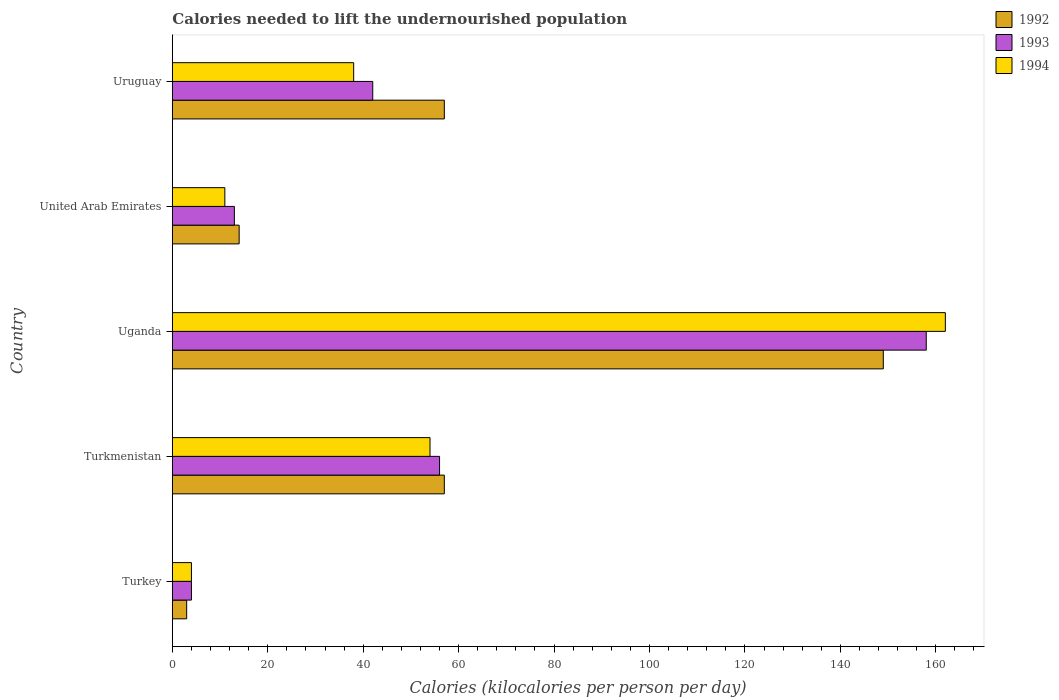How many groups of bars are there?
Your answer should be very brief. 5. Are the number of bars on each tick of the Y-axis equal?
Give a very brief answer. Yes. What is the label of the 2nd group of bars from the top?
Offer a very short reply. United Arab Emirates. Across all countries, what is the maximum total calories needed to lift the undernourished population in 1992?
Your response must be concise. 149. In which country was the total calories needed to lift the undernourished population in 1994 maximum?
Your response must be concise. Uganda. What is the total total calories needed to lift the undernourished population in 1992 in the graph?
Your answer should be very brief. 280. What is the difference between the total calories needed to lift the undernourished population in 1992 in United Arab Emirates and that in Uruguay?
Your answer should be compact. -43. What is the difference between the total calories needed to lift the undernourished population in 1992 in Turkmenistan and the total calories needed to lift the undernourished population in 1993 in Turkey?
Your answer should be compact. 53. What is the average total calories needed to lift the undernourished population in 1992 per country?
Provide a short and direct response. 56. In how many countries, is the total calories needed to lift the undernourished population in 1994 greater than 116 kilocalories?
Ensure brevity in your answer.  1. What is the ratio of the total calories needed to lift the undernourished population in 1993 in Uganda to that in Uruguay?
Offer a terse response. 3.76. Is the total calories needed to lift the undernourished population in 1994 in Turkey less than that in Uruguay?
Keep it short and to the point. Yes. What is the difference between the highest and the second highest total calories needed to lift the undernourished population in 1992?
Your response must be concise. 92. What is the difference between the highest and the lowest total calories needed to lift the undernourished population in 1993?
Your response must be concise. 154. Is the sum of the total calories needed to lift the undernourished population in 1992 in United Arab Emirates and Uruguay greater than the maximum total calories needed to lift the undernourished population in 1994 across all countries?
Give a very brief answer. No. What does the 3rd bar from the top in Uruguay represents?
Your answer should be very brief. 1992. What does the 2nd bar from the bottom in Turkmenistan represents?
Your answer should be compact. 1993. Is it the case that in every country, the sum of the total calories needed to lift the undernourished population in 1994 and total calories needed to lift the undernourished population in 1992 is greater than the total calories needed to lift the undernourished population in 1993?
Make the answer very short. Yes. How many bars are there?
Provide a short and direct response. 15. Are all the bars in the graph horizontal?
Provide a short and direct response. Yes. How many countries are there in the graph?
Keep it short and to the point. 5. What is the difference between two consecutive major ticks on the X-axis?
Your answer should be very brief. 20. Are the values on the major ticks of X-axis written in scientific E-notation?
Offer a terse response. No. Does the graph contain grids?
Give a very brief answer. No. How are the legend labels stacked?
Offer a terse response. Vertical. What is the title of the graph?
Give a very brief answer. Calories needed to lift the undernourished population. What is the label or title of the X-axis?
Your answer should be compact. Calories (kilocalories per person per day). What is the Calories (kilocalories per person per day) in 1994 in Turkey?
Ensure brevity in your answer.  4. What is the Calories (kilocalories per person per day) of 1992 in Turkmenistan?
Provide a short and direct response. 57. What is the Calories (kilocalories per person per day) in 1992 in Uganda?
Your answer should be very brief. 149. What is the Calories (kilocalories per person per day) in 1993 in Uganda?
Your response must be concise. 158. What is the Calories (kilocalories per person per day) of 1994 in Uganda?
Ensure brevity in your answer.  162. What is the Calories (kilocalories per person per day) in 1992 in United Arab Emirates?
Provide a short and direct response. 14. What is the Calories (kilocalories per person per day) in 1993 in United Arab Emirates?
Your answer should be compact. 13. What is the Calories (kilocalories per person per day) of 1994 in United Arab Emirates?
Your answer should be compact. 11. What is the Calories (kilocalories per person per day) of 1992 in Uruguay?
Offer a terse response. 57. What is the Calories (kilocalories per person per day) in 1994 in Uruguay?
Provide a succinct answer. 38. Across all countries, what is the maximum Calories (kilocalories per person per day) in 1992?
Provide a short and direct response. 149. Across all countries, what is the maximum Calories (kilocalories per person per day) in 1993?
Offer a terse response. 158. Across all countries, what is the maximum Calories (kilocalories per person per day) of 1994?
Your answer should be very brief. 162. Across all countries, what is the minimum Calories (kilocalories per person per day) in 1992?
Offer a very short reply. 3. Across all countries, what is the minimum Calories (kilocalories per person per day) in 1994?
Provide a succinct answer. 4. What is the total Calories (kilocalories per person per day) of 1992 in the graph?
Provide a succinct answer. 280. What is the total Calories (kilocalories per person per day) in 1993 in the graph?
Your answer should be very brief. 273. What is the total Calories (kilocalories per person per day) of 1994 in the graph?
Offer a very short reply. 269. What is the difference between the Calories (kilocalories per person per day) in 1992 in Turkey and that in Turkmenistan?
Your response must be concise. -54. What is the difference between the Calories (kilocalories per person per day) of 1993 in Turkey and that in Turkmenistan?
Your answer should be compact. -52. What is the difference between the Calories (kilocalories per person per day) in 1992 in Turkey and that in Uganda?
Provide a short and direct response. -146. What is the difference between the Calories (kilocalories per person per day) of 1993 in Turkey and that in Uganda?
Give a very brief answer. -154. What is the difference between the Calories (kilocalories per person per day) in 1994 in Turkey and that in Uganda?
Ensure brevity in your answer.  -158. What is the difference between the Calories (kilocalories per person per day) of 1994 in Turkey and that in United Arab Emirates?
Offer a very short reply. -7. What is the difference between the Calories (kilocalories per person per day) of 1992 in Turkey and that in Uruguay?
Ensure brevity in your answer.  -54. What is the difference between the Calories (kilocalories per person per day) of 1993 in Turkey and that in Uruguay?
Your answer should be very brief. -38. What is the difference between the Calories (kilocalories per person per day) of 1994 in Turkey and that in Uruguay?
Your response must be concise. -34. What is the difference between the Calories (kilocalories per person per day) of 1992 in Turkmenistan and that in Uganda?
Give a very brief answer. -92. What is the difference between the Calories (kilocalories per person per day) of 1993 in Turkmenistan and that in Uganda?
Give a very brief answer. -102. What is the difference between the Calories (kilocalories per person per day) in 1994 in Turkmenistan and that in Uganda?
Make the answer very short. -108. What is the difference between the Calories (kilocalories per person per day) in 1994 in Turkmenistan and that in United Arab Emirates?
Provide a succinct answer. 43. What is the difference between the Calories (kilocalories per person per day) of 1993 in Turkmenistan and that in Uruguay?
Provide a succinct answer. 14. What is the difference between the Calories (kilocalories per person per day) in 1994 in Turkmenistan and that in Uruguay?
Give a very brief answer. 16. What is the difference between the Calories (kilocalories per person per day) of 1992 in Uganda and that in United Arab Emirates?
Make the answer very short. 135. What is the difference between the Calories (kilocalories per person per day) of 1993 in Uganda and that in United Arab Emirates?
Provide a succinct answer. 145. What is the difference between the Calories (kilocalories per person per day) in 1994 in Uganda and that in United Arab Emirates?
Your answer should be compact. 151. What is the difference between the Calories (kilocalories per person per day) of 1992 in Uganda and that in Uruguay?
Your answer should be compact. 92. What is the difference between the Calories (kilocalories per person per day) in 1993 in Uganda and that in Uruguay?
Ensure brevity in your answer.  116. What is the difference between the Calories (kilocalories per person per day) in 1994 in Uganda and that in Uruguay?
Ensure brevity in your answer.  124. What is the difference between the Calories (kilocalories per person per day) of 1992 in United Arab Emirates and that in Uruguay?
Keep it short and to the point. -43. What is the difference between the Calories (kilocalories per person per day) in 1994 in United Arab Emirates and that in Uruguay?
Keep it short and to the point. -27. What is the difference between the Calories (kilocalories per person per day) of 1992 in Turkey and the Calories (kilocalories per person per day) of 1993 in Turkmenistan?
Your response must be concise. -53. What is the difference between the Calories (kilocalories per person per day) of 1992 in Turkey and the Calories (kilocalories per person per day) of 1994 in Turkmenistan?
Your response must be concise. -51. What is the difference between the Calories (kilocalories per person per day) of 1993 in Turkey and the Calories (kilocalories per person per day) of 1994 in Turkmenistan?
Make the answer very short. -50. What is the difference between the Calories (kilocalories per person per day) in 1992 in Turkey and the Calories (kilocalories per person per day) in 1993 in Uganda?
Provide a succinct answer. -155. What is the difference between the Calories (kilocalories per person per day) in 1992 in Turkey and the Calories (kilocalories per person per day) in 1994 in Uganda?
Your answer should be compact. -159. What is the difference between the Calories (kilocalories per person per day) in 1993 in Turkey and the Calories (kilocalories per person per day) in 1994 in Uganda?
Provide a short and direct response. -158. What is the difference between the Calories (kilocalories per person per day) in 1992 in Turkey and the Calories (kilocalories per person per day) in 1993 in Uruguay?
Offer a terse response. -39. What is the difference between the Calories (kilocalories per person per day) in 1992 in Turkey and the Calories (kilocalories per person per day) in 1994 in Uruguay?
Your answer should be compact. -35. What is the difference between the Calories (kilocalories per person per day) in 1993 in Turkey and the Calories (kilocalories per person per day) in 1994 in Uruguay?
Your answer should be very brief. -34. What is the difference between the Calories (kilocalories per person per day) of 1992 in Turkmenistan and the Calories (kilocalories per person per day) of 1993 in Uganda?
Your response must be concise. -101. What is the difference between the Calories (kilocalories per person per day) of 1992 in Turkmenistan and the Calories (kilocalories per person per day) of 1994 in Uganda?
Provide a succinct answer. -105. What is the difference between the Calories (kilocalories per person per day) of 1993 in Turkmenistan and the Calories (kilocalories per person per day) of 1994 in Uganda?
Your answer should be very brief. -106. What is the difference between the Calories (kilocalories per person per day) in 1992 in Turkmenistan and the Calories (kilocalories per person per day) in 1993 in United Arab Emirates?
Your answer should be very brief. 44. What is the difference between the Calories (kilocalories per person per day) in 1992 in Turkmenistan and the Calories (kilocalories per person per day) in 1993 in Uruguay?
Offer a terse response. 15. What is the difference between the Calories (kilocalories per person per day) of 1992 in Turkmenistan and the Calories (kilocalories per person per day) of 1994 in Uruguay?
Provide a succinct answer. 19. What is the difference between the Calories (kilocalories per person per day) in 1993 in Turkmenistan and the Calories (kilocalories per person per day) in 1994 in Uruguay?
Your answer should be very brief. 18. What is the difference between the Calories (kilocalories per person per day) in 1992 in Uganda and the Calories (kilocalories per person per day) in 1993 in United Arab Emirates?
Give a very brief answer. 136. What is the difference between the Calories (kilocalories per person per day) of 1992 in Uganda and the Calories (kilocalories per person per day) of 1994 in United Arab Emirates?
Your response must be concise. 138. What is the difference between the Calories (kilocalories per person per day) of 1993 in Uganda and the Calories (kilocalories per person per day) of 1994 in United Arab Emirates?
Make the answer very short. 147. What is the difference between the Calories (kilocalories per person per day) in 1992 in Uganda and the Calories (kilocalories per person per day) in 1993 in Uruguay?
Keep it short and to the point. 107. What is the difference between the Calories (kilocalories per person per day) in 1992 in Uganda and the Calories (kilocalories per person per day) in 1994 in Uruguay?
Your response must be concise. 111. What is the difference between the Calories (kilocalories per person per day) in 1993 in Uganda and the Calories (kilocalories per person per day) in 1994 in Uruguay?
Offer a terse response. 120. What is the difference between the Calories (kilocalories per person per day) in 1992 in United Arab Emirates and the Calories (kilocalories per person per day) in 1994 in Uruguay?
Give a very brief answer. -24. What is the difference between the Calories (kilocalories per person per day) of 1993 in United Arab Emirates and the Calories (kilocalories per person per day) of 1994 in Uruguay?
Provide a succinct answer. -25. What is the average Calories (kilocalories per person per day) of 1993 per country?
Your answer should be very brief. 54.6. What is the average Calories (kilocalories per person per day) of 1994 per country?
Provide a short and direct response. 53.8. What is the difference between the Calories (kilocalories per person per day) in 1992 and Calories (kilocalories per person per day) in 1993 in Turkmenistan?
Provide a succinct answer. 1. What is the difference between the Calories (kilocalories per person per day) in 1992 and Calories (kilocalories per person per day) in 1994 in Uganda?
Offer a very short reply. -13. What is the difference between the Calories (kilocalories per person per day) in 1993 and Calories (kilocalories per person per day) in 1994 in Uganda?
Offer a very short reply. -4. What is the difference between the Calories (kilocalories per person per day) in 1992 and Calories (kilocalories per person per day) in 1993 in United Arab Emirates?
Your answer should be compact. 1. What is the difference between the Calories (kilocalories per person per day) in 1993 and Calories (kilocalories per person per day) in 1994 in United Arab Emirates?
Your answer should be compact. 2. What is the difference between the Calories (kilocalories per person per day) in 1992 and Calories (kilocalories per person per day) in 1993 in Uruguay?
Give a very brief answer. 15. What is the difference between the Calories (kilocalories per person per day) in 1992 and Calories (kilocalories per person per day) in 1994 in Uruguay?
Your response must be concise. 19. What is the ratio of the Calories (kilocalories per person per day) in 1992 in Turkey to that in Turkmenistan?
Make the answer very short. 0.05. What is the ratio of the Calories (kilocalories per person per day) of 1993 in Turkey to that in Turkmenistan?
Provide a short and direct response. 0.07. What is the ratio of the Calories (kilocalories per person per day) of 1994 in Turkey to that in Turkmenistan?
Give a very brief answer. 0.07. What is the ratio of the Calories (kilocalories per person per day) in 1992 in Turkey to that in Uganda?
Offer a very short reply. 0.02. What is the ratio of the Calories (kilocalories per person per day) of 1993 in Turkey to that in Uganda?
Provide a succinct answer. 0.03. What is the ratio of the Calories (kilocalories per person per day) of 1994 in Turkey to that in Uganda?
Your answer should be compact. 0.02. What is the ratio of the Calories (kilocalories per person per day) in 1992 in Turkey to that in United Arab Emirates?
Offer a terse response. 0.21. What is the ratio of the Calories (kilocalories per person per day) in 1993 in Turkey to that in United Arab Emirates?
Make the answer very short. 0.31. What is the ratio of the Calories (kilocalories per person per day) in 1994 in Turkey to that in United Arab Emirates?
Give a very brief answer. 0.36. What is the ratio of the Calories (kilocalories per person per day) of 1992 in Turkey to that in Uruguay?
Offer a very short reply. 0.05. What is the ratio of the Calories (kilocalories per person per day) of 1993 in Turkey to that in Uruguay?
Offer a very short reply. 0.1. What is the ratio of the Calories (kilocalories per person per day) in 1994 in Turkey to that in Uruguay?
Give a very brief answer. 0.11. What is the ratio of the Calories (kilocalories per person per day) in 1992 in Turkmenistan to that in Uganda?
Your response must be concise. 0.38. What is the ratio of the Calories (kilocalories per person per day) of 1993 in Turkmenistan to that in Uganda?
Keep it short and to the point. 0.35. What is the ratio of the Calories (kilocalories per person per day) of 1994 in Turkmenistan to that in Uganda?
Your answer should be very brief. 0.33. What is the ratio of the Calories (kilocalories per person per day) of 1992 in Turkmenistan to that in United Arab Emirates?
Your answer should be compact. 4.07. What is the ratio of the Calories (kilocalories per person per day) of 1993 in Turkmenistan to that in United Arab Emirates?
Your response must be concise. 4.31. What is the ratio of the Calories (kilocalories per person per day) in 1994 in Turkmenistan to that in United Arab Emirates?
Your response must be concise. 4.91. What is the ratio of the Calories (kilocalories per person per day) of 1994 in Turkmenistan to that in Uruguay?
Provide a succinct answer. 1.42. What is the ratio of the Calories (kilocalories per person per day) of 1992 in Uganda to that in United Arab Emirates?
Ensure brevity in your answer.  10.64. What is the ratio of the Calories (kilocalories per person per day) of 1993 in Uganda to that in United Arab Emirates?
Give a very brief answer. 12.15. What is the ratio of the Calories (kilocalories per person per day) in 1994 in Uganda to that in United Arab Emirates?
Your response must be concise. 14.73. What is the ratio of the Calories (kilocalories per person per day) in 1992 in Uganda to that in Uruguay?
Offer a terse response. 2.61. What is the ratio of the Calories (kilocalories per person per day) in 1993 in Uganda to that in Uruguay?
Provide a short and direct response. 3.76. What is the ratio of the Calories (kilocalories per person per day) of 1994 in Uganda to that in Uruguay?
Offer a terse response. 4.26. What is the ratio of the Calories (kilocalories per person per day) of 1992 in United Arab Emirates to that in Uruguay?
Your response must be concise. 0.25. What is the ratio of the Calories (kilocalories per person per day) in 1993 in United Arab Emirates to that in Uruguay?
Offer a terse response. 0.31. What is the ratio of the Calories (kilocalories per person per day) in 1994 in United Arab Emirates to that in Uruguay?
Offer a very short reply. 0.29. What is the difference between the highest and the second highest Calories (kilocalories per person per day) in 1992?
Offer a terse response. 92. What is the difference between the highest and the second highest Calories (kilocalories per person per day) in 1993?
Your answer should be very brief. 102. What is the difference between the highest and the second highest Calories (kilocalories per person per day) in 1994?
Your answer should be compact. 108. What is the difference between the highest and the lowest Calories (kilocalories per person per day) of 1992?
Keep it short and to the point. 146. What is the difference between the highest and the lowest Calories (kilocalories per person per day) in 1993?
Provide a short and direct response. 154. What is the difference between the highest and the lowest Calories (kilocalories per person per day) in 1994?
Your answer should be compact. 158. 